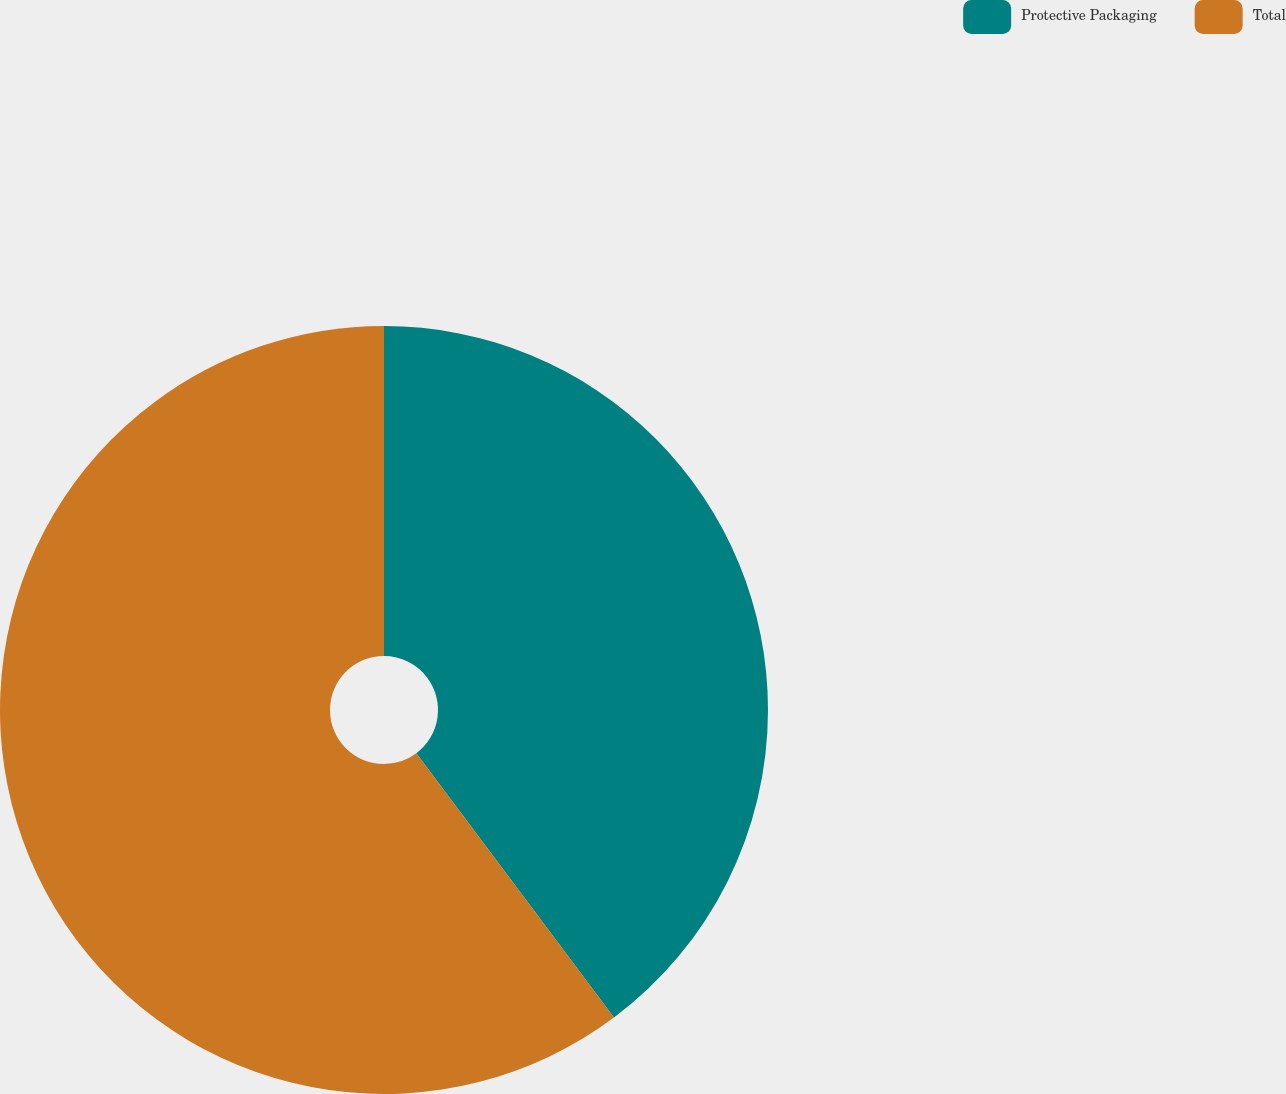Convert chart to OTSL. <chart><loc_0><loc_0><loc_500><loc_500><pie_chart><fcel>Protective Packaging<fcel>Total<nl><fcel>39.78%<fcel>60.22%<nl></chart> 